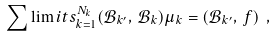Convert formula to latex. <formula><loc_0><loc_0><loc_500><loc_500>\sum \lim i t s _ { k = 1 } ^ { N _ { k } } ( { \mathcal { B } } _ { k ^ { \prime } } , \, { \mathcal { B } } _ { k } ) { \mu } _ { k } = ( { \mathcal { B } } _ { k ^ { \prime } } , \, f ) \ ,</formula> 